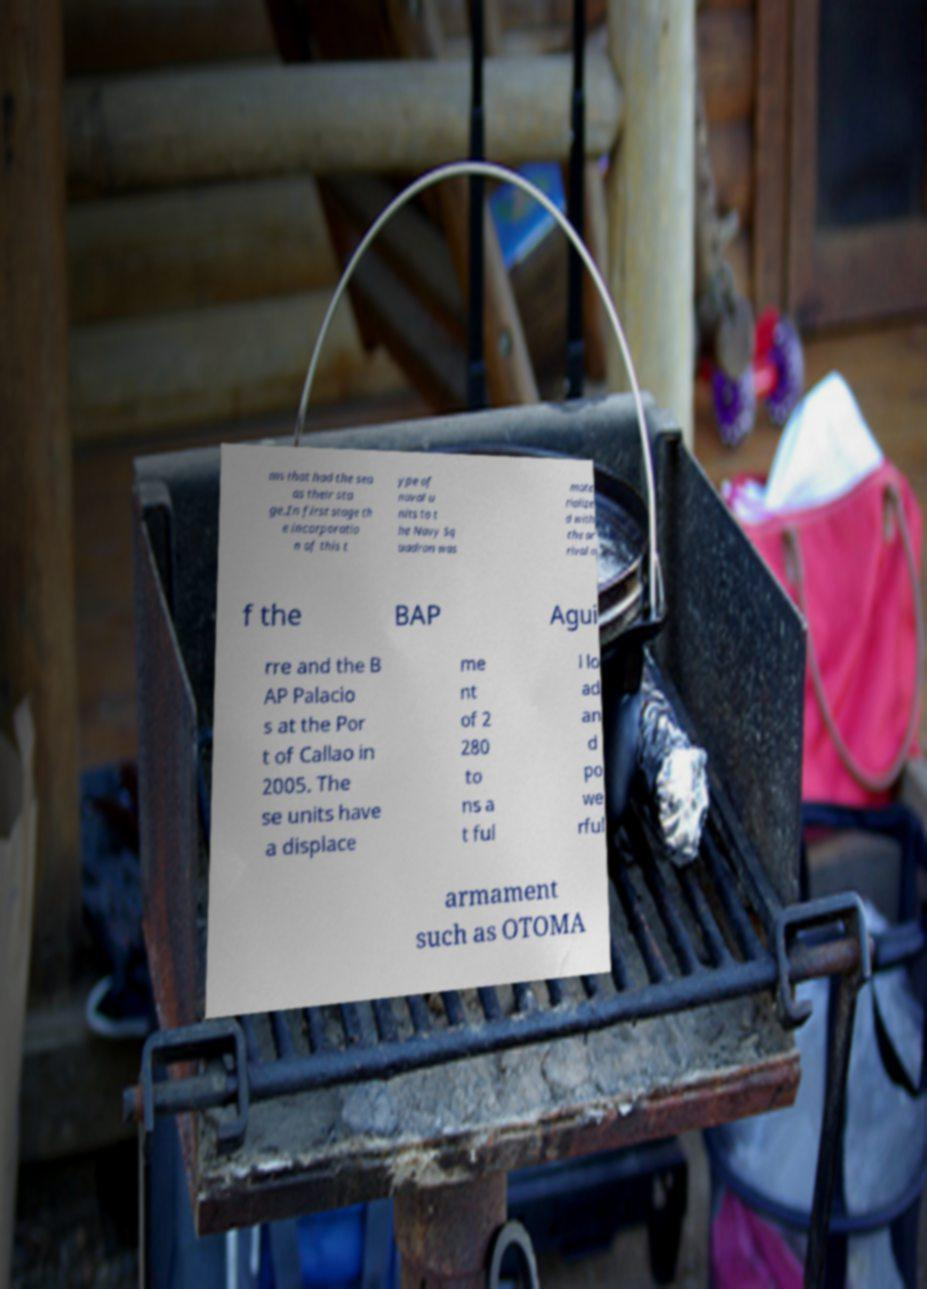Can you accurately transcribe the text from the provided image for me? ms that had the sea as their sta ge.In first stage th e incorporatio n of this t ype of naval u nits to t he Navy Sq uadron was mate rialize d with the ar rival o f the BAP Agui rre and the B AP Palacio s at the Por t of Callao in 2005. The se units have a displace me nt of 2 280 to ns a t ful l lo ad an d po we rful armament such as OTOMA 